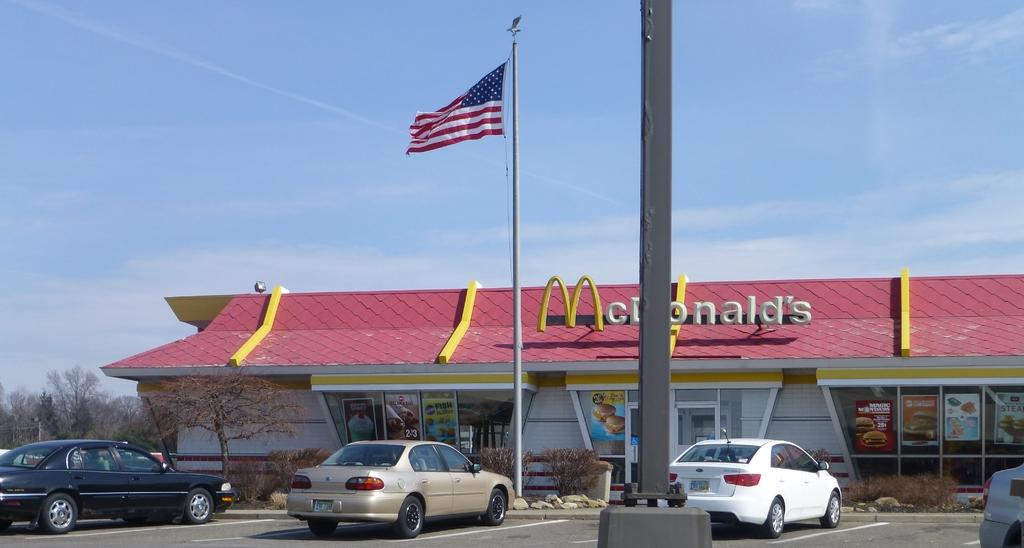What type of establishment is shown in the image? The image depicts a restaurant. What can be seen in front of the restaurant? There is a pole with a flag in front of the restaurant. How many cars are parked on the road? Four cars are parked on the road. What type of vegetation is present on the left side of the image? There are trees present on the left side of the image. What is visible at the top of the image? The sky is visible at the top of the image. What type of bell can be heard ringing in the image? There is no bell present or audible in the image. Are there any dinosaurs visible in the image? No, there are no dinosaurs present in the image. 